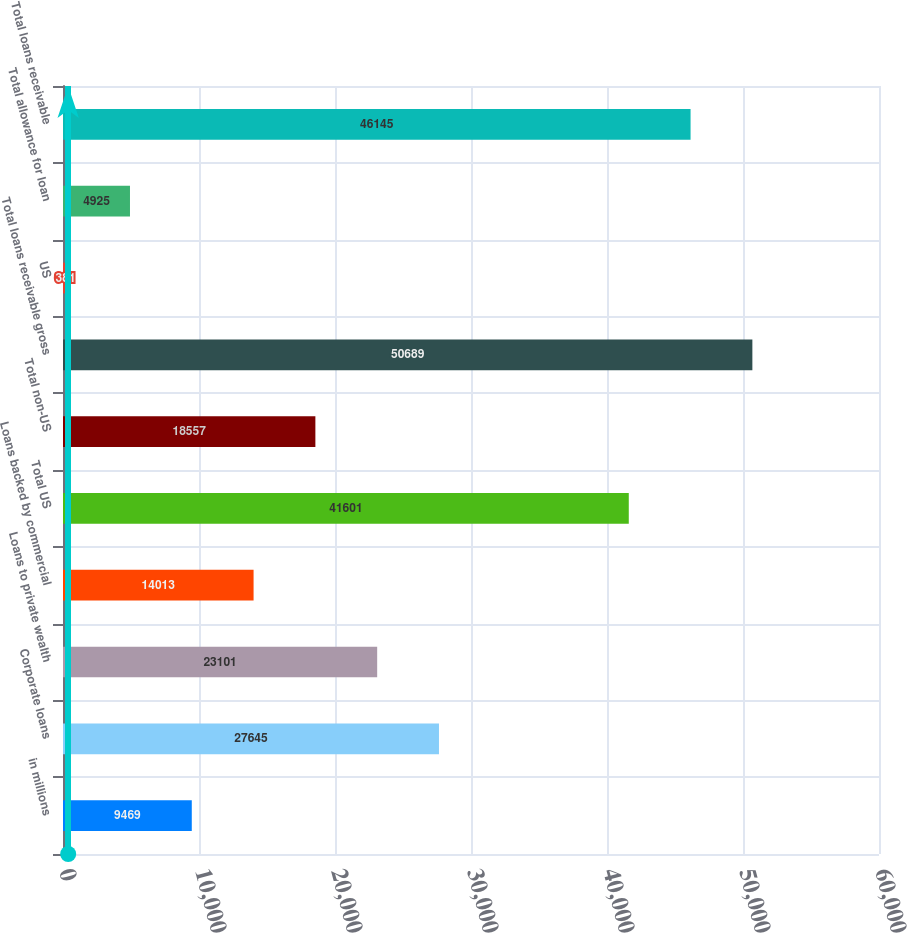Convert chart. <chart><loc_0><loc_0><loc_500><loc_500><bar_chart><fcel>in millions<fcel>Corporate loans<fcel>Loans to private wealth<fcel>Loans backed by commercial<fcel>Total US<fcel>Total non-US<fcel>Total loans receivable gross<fcel>US<fcel>Total allowance for loan<fcel>Total loans receivable<nl><fcel>9469<fcel>27645<fcel>23101<fcel>14013<fcel>41601<fcel>18557<fcel>50689<fcel>381<fcel>4925<fcel>46145<nl></chart> 